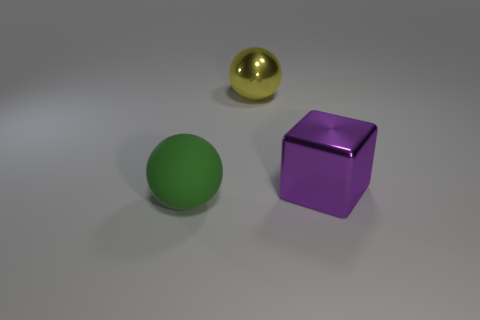Add 2 big green balls. How many objects exist? 5 Subtract 0 brown cubes. How many objects are left? 3 Subtract all balls. How many objects are left? 1 Subtract 1 blocks. How many blocks are left? 0 Subtract all yellow balls. Subtract all brown blocks. How many balls are left? 1 Subtract all brown spheres. How many red cubes are left? 0 Subtract all large purple shiny cubes. Subtract all big yellow objects. How many objects are left? 1 Add 2 purple metal blocks. How many purple metal blocks are left? 3 Add 1 large yellow metallic cylinders. How many large yellow metallic cylinders exist? 1 Subtract all yellow balls. How many balls are left? 1 